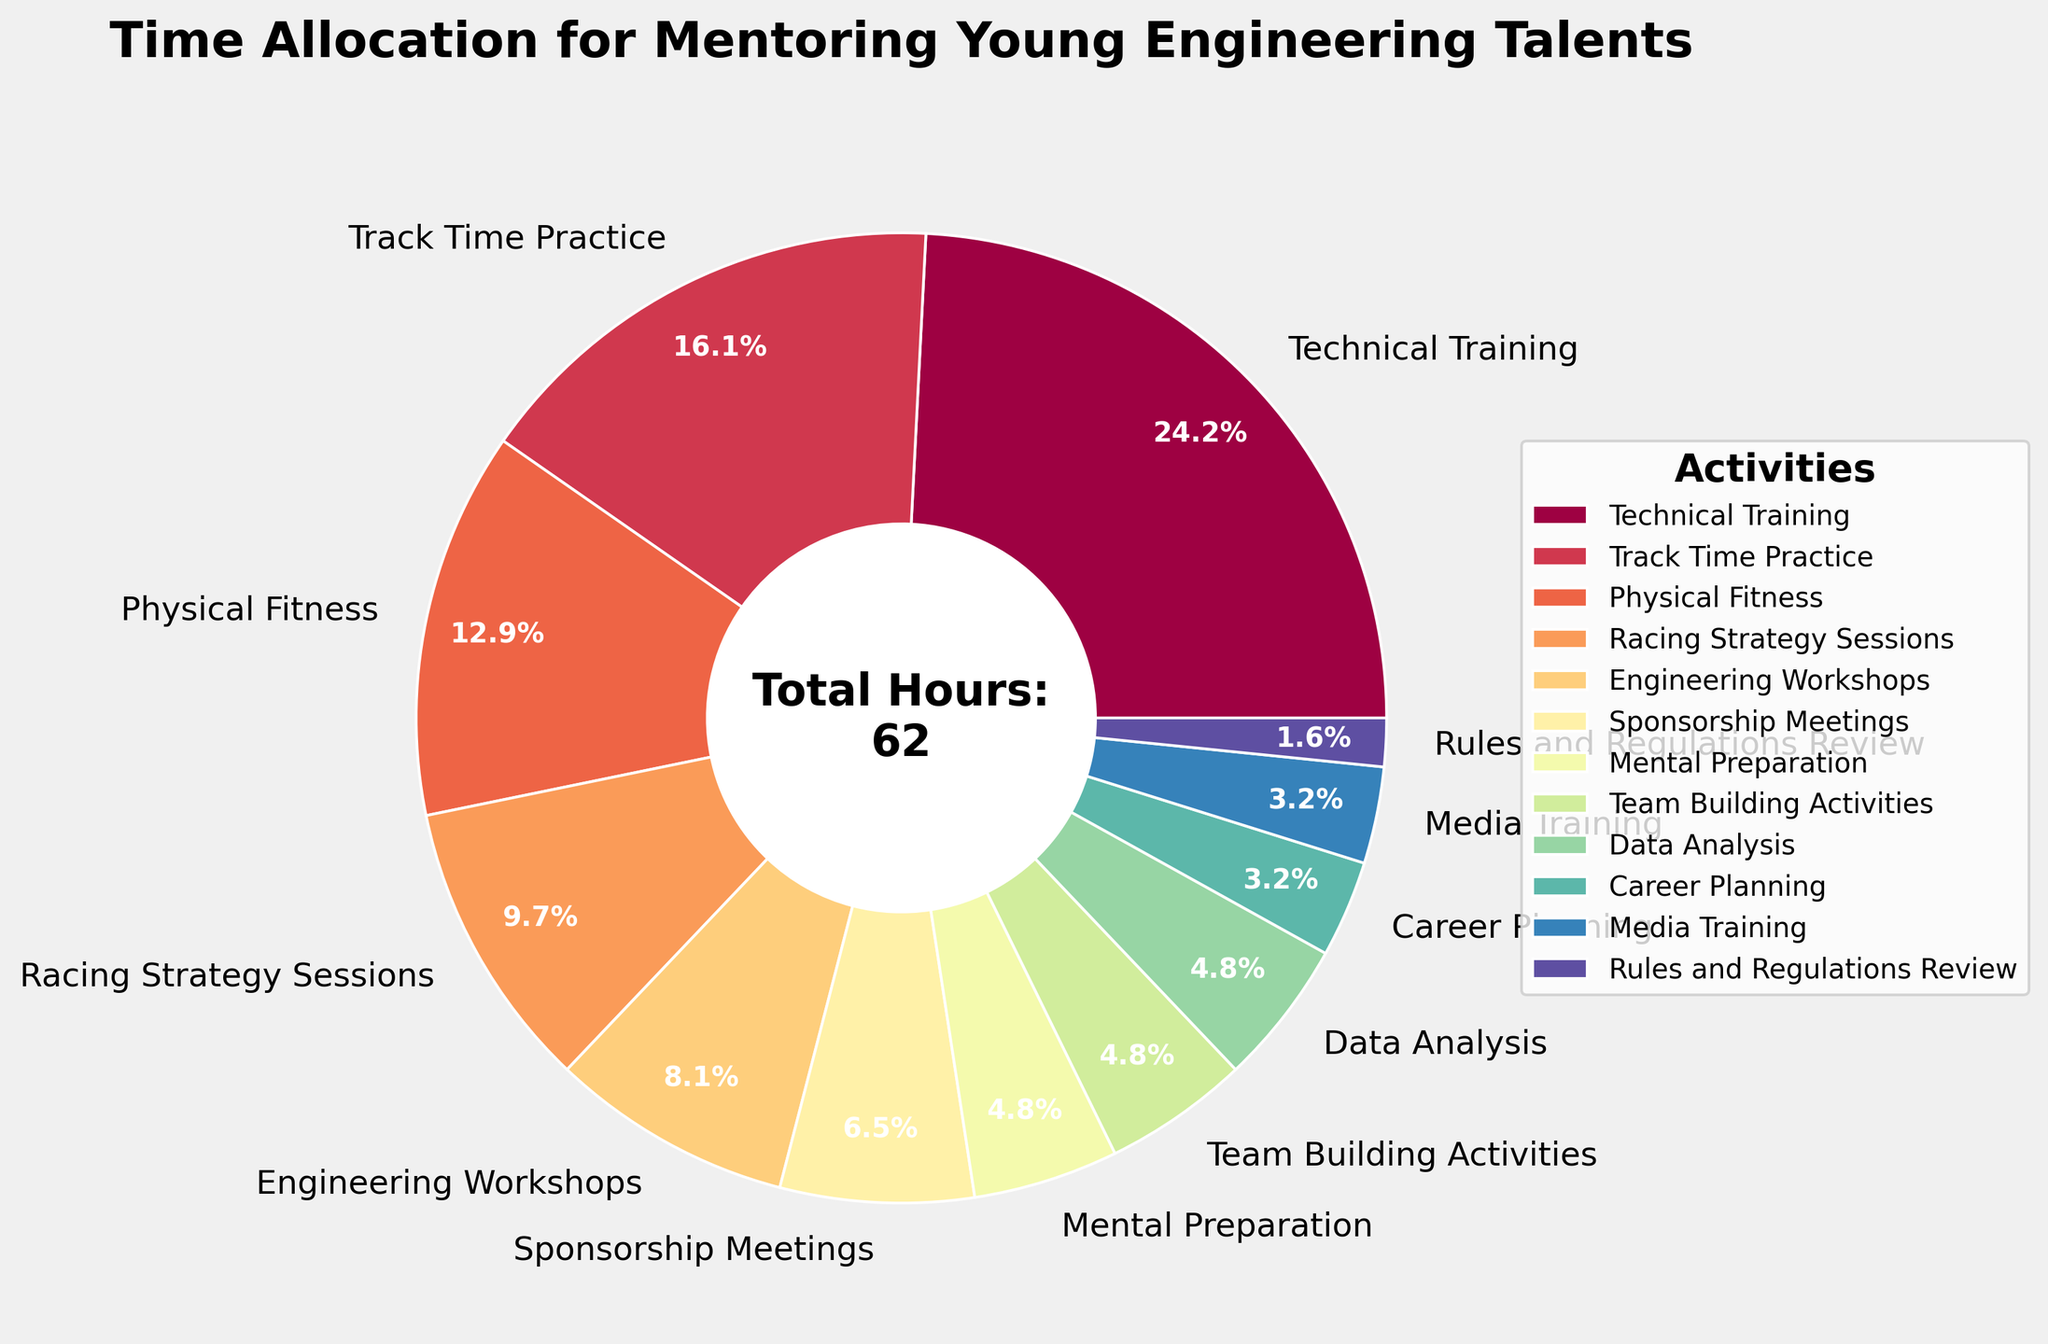Which activity takes up the largest amount of time per week? The activity that takes up the largest amount of time can be identified by looking for the largest section in the pie chart, which is the most prominent in terms of size.
Answer: Technical Training Which two activities are allocated the same amount of time? By comparing the size of sections and referencing the labels, identify two activities with equal time allocation.
Answer: Mental Preparation, Team Building Activities, and Data Analysis How many hours per week are allocated to Engineering Workshops and Sponsorship Meetings combined? Find the hours for Engineering Workshops (5 hours) and Sponsorship Meetings (4 hours), then add them together. 5 + 4 = 9
Answer: 9 What percentage of total weekly hours is spent on Technical Training? Find the section labeled Technical Training and read its percentage from the pie chart. The label directly shows the percentage.
Answer: 24.2% Compare the time allocated to Physical Fitness and Career Planning. Which one has more hours, and by how much? Identify the hours for Physical Fitness (8) and Career Planning (2), then calculate the difference (8 - 2).
Answer: Physical Fitness by 6 hours What is the total percentage of time spent on Technical Training and Track Time Practice combined? Find the percentage for Technical Training (24.2%) and Track Time Practice (16.1%) and add them together. 24.2 + 16.1 = 40.3
Answer: 40.3% Which activity has the lowest time allocation and how many hours does it take per week? Look for the smallest section in the pie chart or identify the label with the smallest time allocation.
Answer: Rules and Regulations Review, 1 hour What is the difference in percentage points between time allocated for Racing Strategy Sessions and Media Training? Find the percentage for Racing Strategy Sessions (9.7%) and Media Training (3.2%). Subtract the smaller from the larger (9.7 - 3.2).
Answer: 6.5% How many hours less are spent on Mental Preparation compared to Technical Training per week? Identify the hours for Mental Preparation (3) and Technical Training (15), then calculate the difference (15 - 3).
Answer: 12 What proportion of the total time is spent on activities that directly relate to physical conditioning, combining Physical Fitness and Mental Preparation? Find the hours for Physical Fitness (8) and Mental Preparation (3), add them together (8 + 3) and compute it as a proportion of the total hours (11/62). Converting this to a percentage (11/62)*100 ≈ 17.7%.
Answer: 17.7% 